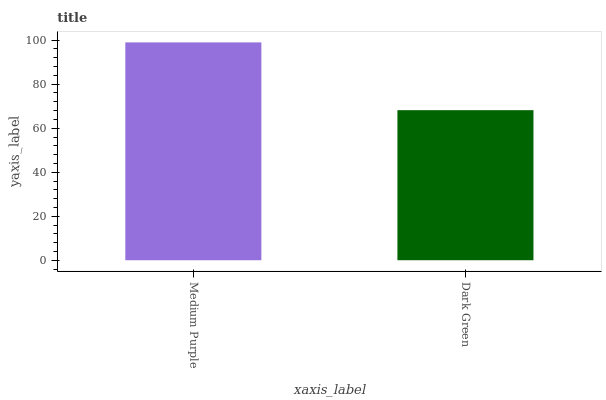Is Dark Green the minimum?
Answer yes or no. Yes. Is Medium Purple the maximum?
Answer yes or no. Yes. Is Dark Green the maximum?
Answer yes or no. No. Is Medium Purple greater than Dark Green?
Answer yes or no. Yes. Is Dark Green less than Medium Purple?
Answer yes or no. Yes. Is Dark Green greater than Medium Purple?
Answer yes or no. No. Is Medium Purple less than Dark Green?
Answer yes or no. No. Is Medium Purple the high median?
Answer yes or no. Yes. Is Dark Green the low median?
Answer yes or no. Yes. Is Dark Green the high median?
Answer yes or no. No. Is Medium Purple the low median?
Answer yes or no. No. 